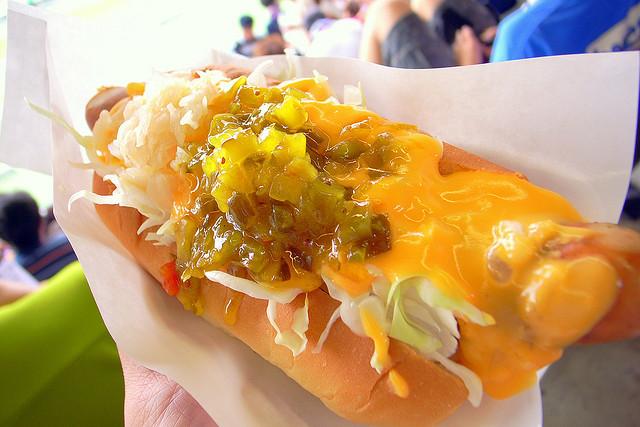Was this picture taken in a person's home?
Concise answer only. No. Does this look like a healthy meal?
Answer briefly. No. How many toppings are on this hot dog?
Keep it brief. 4. 